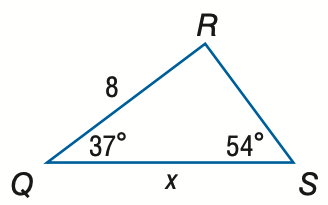Answer the mathemtical geometry problem and directly provide the correct option letter.
Question: Find x. Round to the nearest tenth.
Choices: A: 6.5 B: 9.9 C: 10.8 D: 13.3 B 